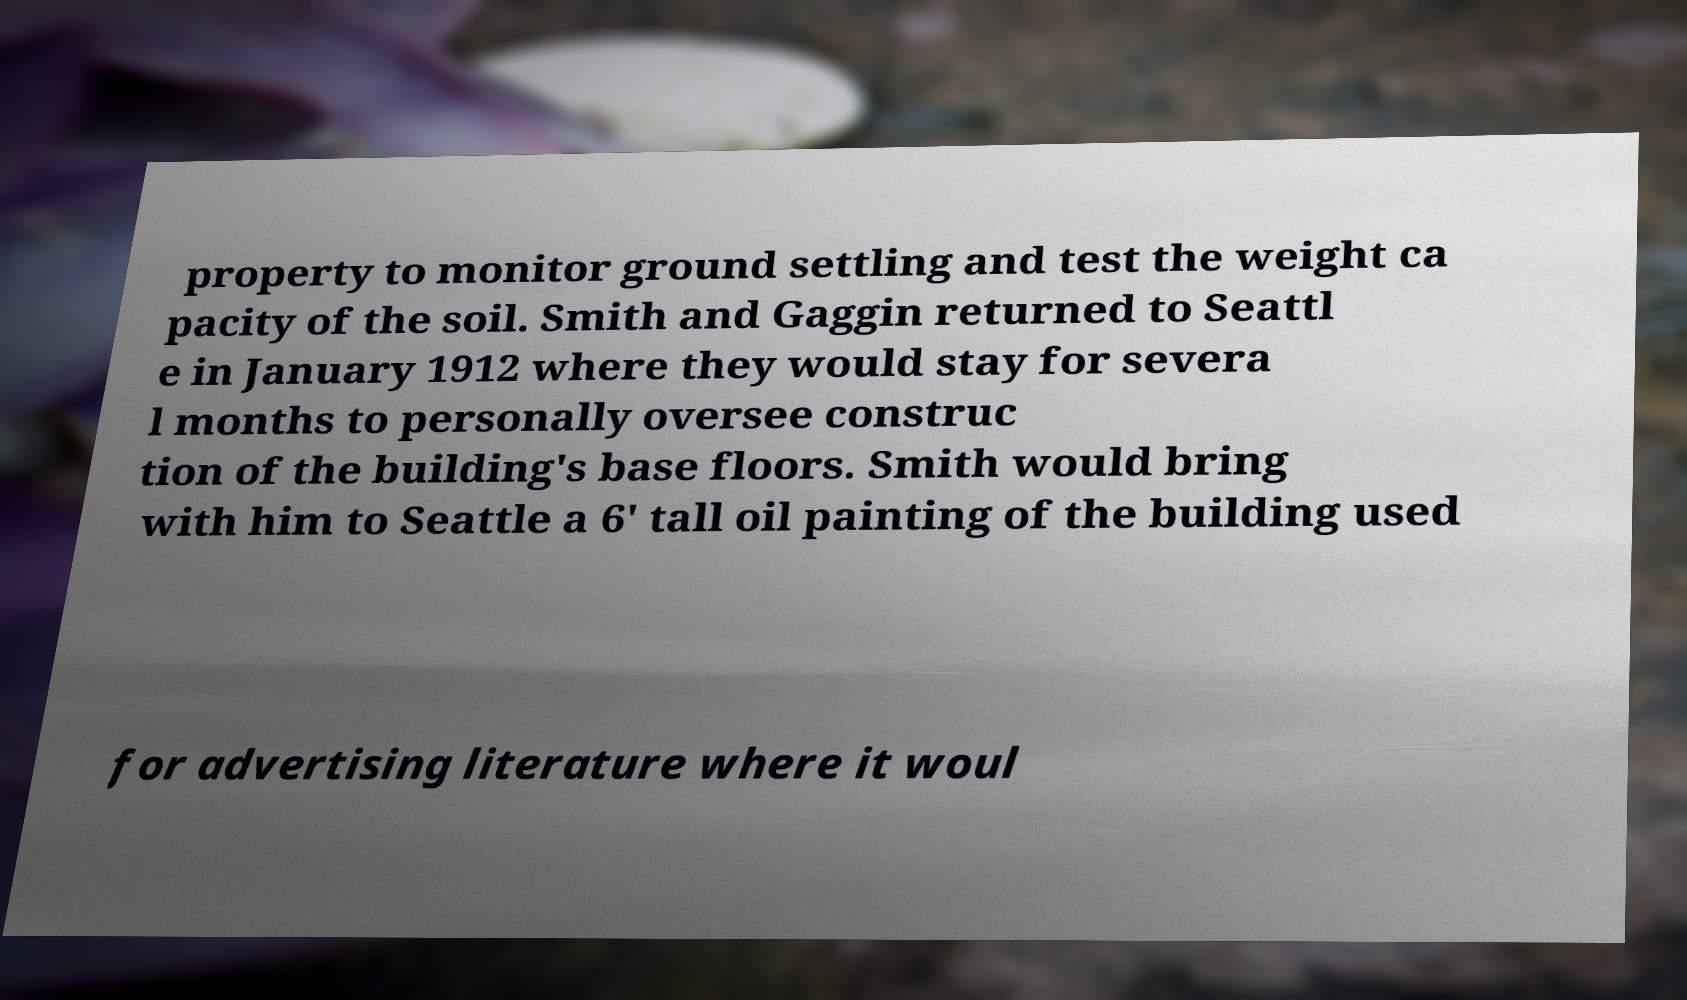Please read and relay the text visible in this image. What does it say? property to monitor ground settling and test the weight ca pacity of the soil. Smith and Gaggin returned to Seattl e in January 1912 where they would stay for severa l months to personally oversee construc tion of the building's base floors. Smith would bring with him to Seattle a 6' tall oil painting of the building used for advertising literature where it woul 